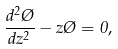Convert formula to latex. <formula><loc_0><loc_0><loc_500><loc_500>\frac { d ^ { 2 } \chi } { d z ^ { 2 } } - z \chi = 0 ,</formula> 